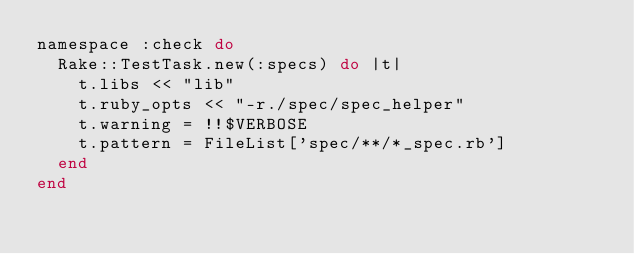Convert code to text. <code><loc_0><loc_0><loc_500><loc_500><_Ruby_>namespace :check do
  Rake::TestTask.new(:specs) do |t|
    t.libs << "lib"
    t.ruby_opts << "-r./spec/spec_helper"
    t.warning = !!$VERBOSE
    t.pattern = FileList['spec/**/*_spec.rb']
  end
end
</code> 